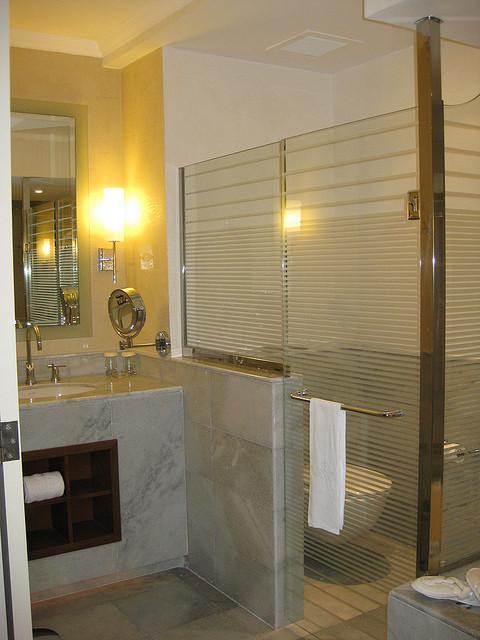How many horses are there?
Give a very brief answer. 0. 